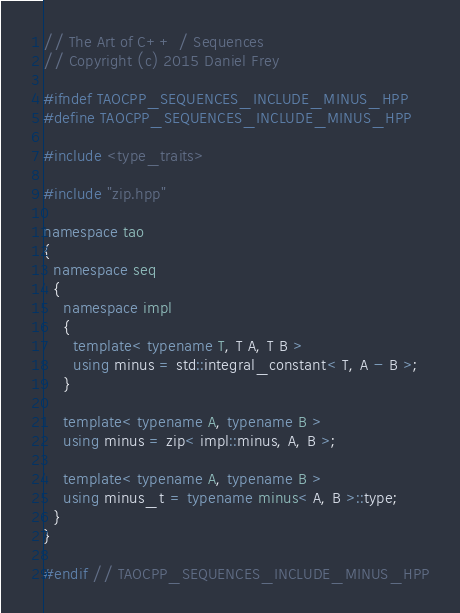Convert code to text. <code><loc_0><loc_0><loc_500><loc_500><_C++_>// The Art of C++ / Sequences
// Copyright (c) 2015 Daniel Frey

#ifndef TAOCPP_SEQUENCES_INCLUDE_MINUS_HPP
#define TAOCPP_SEQUENCES_INCLUDE_MINUS_HPP

#include <type_traits>

#include "zip.hpp"

namespace tao
{
  namespace seq
  {
    namespace impl
    {
      template< typename T, T A, T B >
      using minus = std::integral_constant< T, A - B >;
    }

    template< typename A, typename B >
    using minus = zip< impl::minus, A, B >;

    template< typename A, typename B >
    using minus_t = typename minus< A, B >::type;
  }
}

#endif // TAOCPP_SEQUENCES_INCLUDE_MINUS_HPP
</code> 